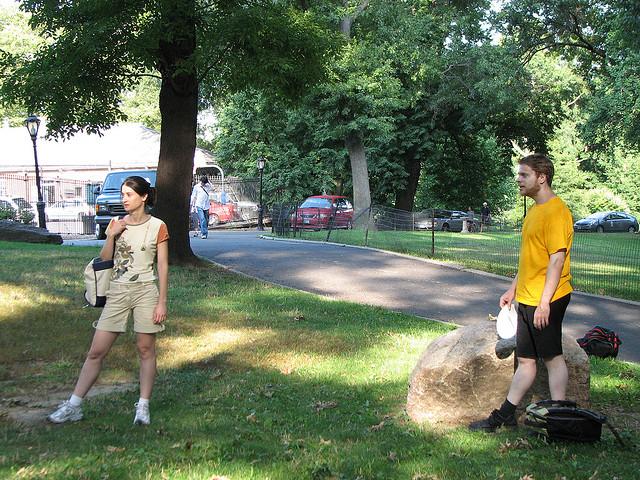Anyone wearing shorts?
Keep it brief. Yes. Is the girl also playing Frisbee?
Concise answer only. No. Why is there a backpack simply sitting by the road in the background?
Give a very brief answer. Yes. 